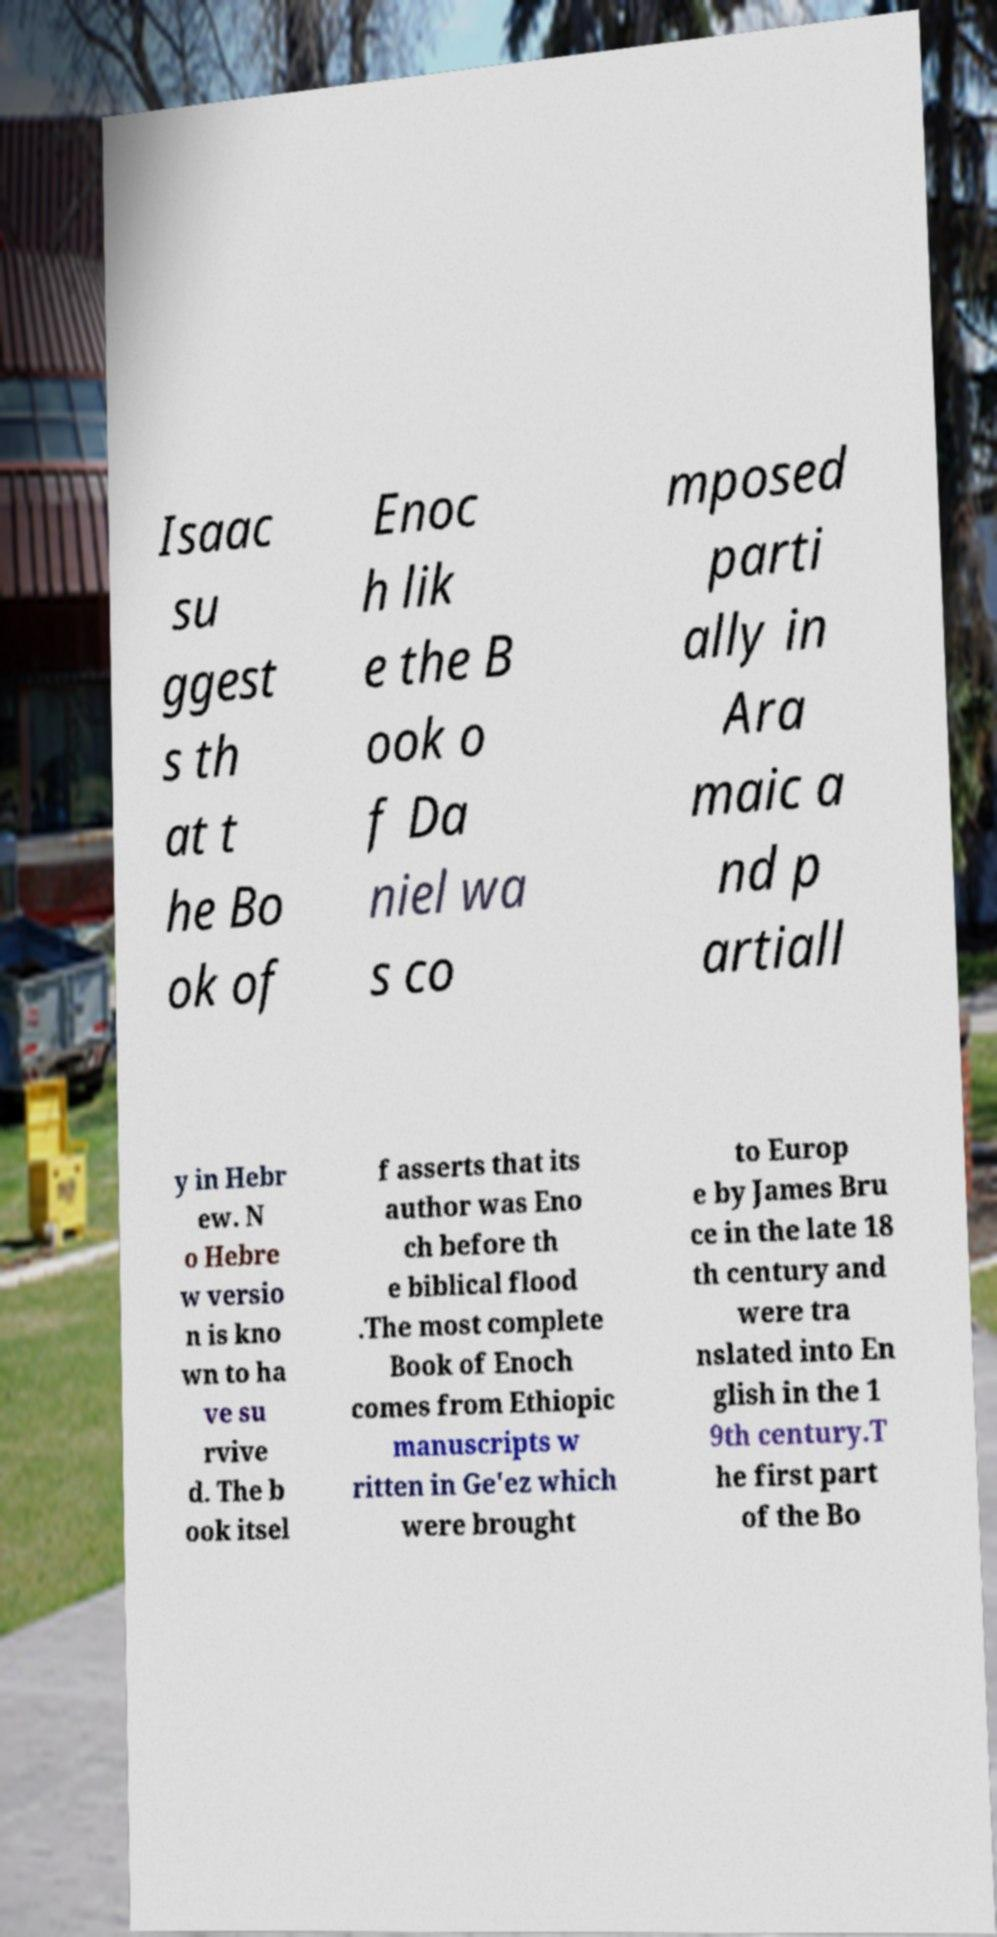There's text embedded in this image that I need extracted. Can you transcribe it verbatim? Isaac su ggest s th at t he Bo ok of Enoc h lik e the B ook o f Da niel wa s co mposed parti ally in Ara maic a nd p artiall y in Hebr ew. N o Hebre w versio n is kno wn to ha ve su rvive d. The b ook itsel f asserts that its author was Eno ch before th e biblical flood .The most complete Book of Enoch comes from Ethiopic manuscripts w ritten in Ge'ez which were brought to Europ e by James Bru ce in the late 18 th century and were tra nslated into En glish in the 1 9th century.T he first part of the Bo 